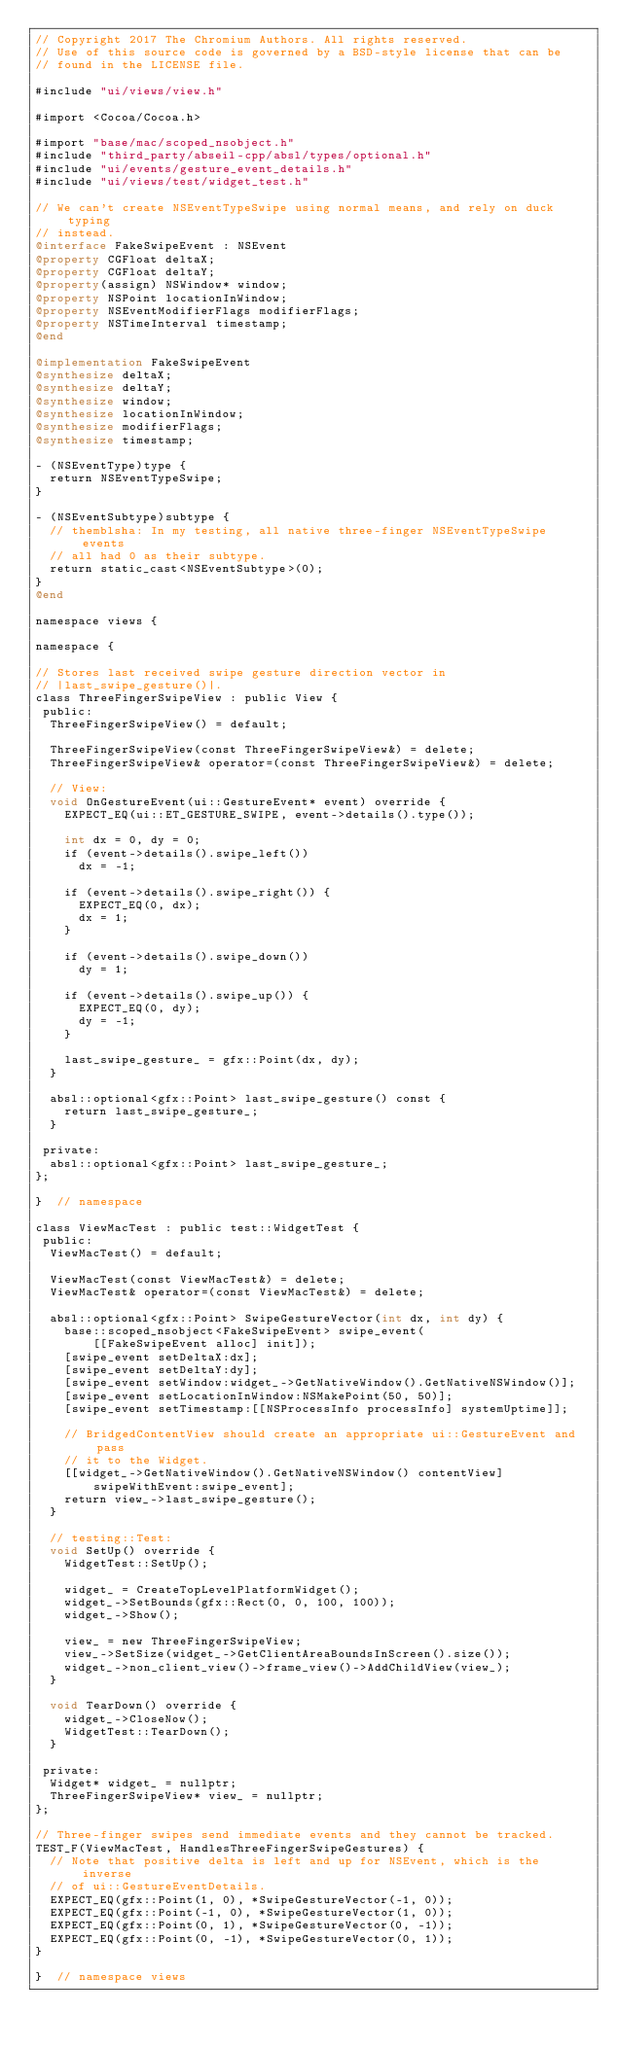<code> <loc_0><loc_0><loc_500><loc_500><_ObjectiveC_>// Copyright 2017 The Chromium Authors. All rights reserved.
// Use of this source code is governed by a BSD-style license that can be
// found in the LICENSE file.

#include "ui/views/view.h"

#import <Cocoa/Cocoa.h>

#import "base/mac/scoped_nsobject.h"
#include "third_party/abseil-cpp/absl/types/optional.h"
#include "ui/events/gesture_event_details.h"
#include "ui/views/test/widget_test.h"

// We can't create NSEventTypeSwipe using normal means, and rely on duck typing
// instead.
@interface FakeSwipeEvent : NSEvent
@property CGFloat deltaX;
@property CGFloat deltaY;
@property(assign) NSWindow* window;
@property NSPoint locationInWindow;
@property NSEventModifierFlags modifierFlags;
@property NSTimeInterval timestamp;
@end

@implementation FakeSwipeEvent
@synthesize deltaX;
@synthesize deltaY;
@synthesize window;
@synthesize locationInWindow;
@synthesize modifierFlags;
@synthesize timestamp;

- (NSEventType)type {
  return NSEventTypeSwipe;
}

- (NSEventSubtype)subtype {
  // themblsha: In my testing, all native three-finger NSEventTypeSwipe events
  // all had 0 as their subtype.
  return static_cast<NSEventSubtype>(0);
}
@end

namespace views {

namespace {

// Stores last received swipe gesture direction vector in
// |last_swipe_gesture()|.
class ThreeFingerSwipeView : public View {
 public:
  ThreeFingerSwipeView() = default;

  ThreeFingerSwipeView(const ThreeFingerSwipeView&) = delete;
  ThreeFingerSwipeView& operator=(const ThreeFingerSwipeView&) = delete;

  // View:
  void OnGestureEvent(ui::GestureEvent* event) override {
    EXPECT_EQ(ui::ET_GESTURE_SWIPE, event->details().type());

    int dx = 0, dy = 0;
    if (event->details().swipe_left())
      dx = -1;

    if (event->details().swipe_right()) {
      EXPECT_EQ(0, dx);
      dx = 1;
    }

    if (event->details().swipe_down())
      dy = 1;

    if (event->details().swipe_up()) {
      EXPECT_EQ(0, dy);
      dy = -1;
    }

    last_swipe_gesture_ = gfx::Point(dx, dy);
  }

  absl::optional<gfx::Point> last_swipe_gesture() const {
    return last_swipe_gesture_;
  }

 private:
  absl::optional<gfx::Point> last_swipe_gesture_;
};

}  // namespace

class ViewMacTest : public test::WidgetTest {
 public:
  ViewMacTest() = default;

  ViewMacTest(const ViewMacTest&) = delete;
  ViewMacTest& operator=(const ViewMacTest&) = delete;

  absl::optional<gfx::Point> SwipeGestureVector(int dx, int dy) {
    base::scoped_nsobject<FakeSwipeEvent> swipe_event(
        [[FakeSwipeEvent alloc] init]);
    [swipe_event setDeltaX:dx];
    [swipe_event setDeltaY:dy];
    [swipe_event setWindow:widget_->GetNativeWindow().GetNativeNSWindow()];
    [swipe_event setLocationInWindow:NSMakePoint(50, 50)];
    [swipe_event setTimestamp:[[NSProcessInfo processInfo] systemUptime]];

    // BridgedContentView should create an appropriate ui::GestureEvent and pass
    // it to the Widget.
    [[widget_->GetNativeWindow().GetNativeNSWindow() contentView]
        swipeWithEvent:swipe_event];
    return view_->last_swipe_gesture();
  }

  // testing::Test:
  void SetUp() override {
    WidgetTest::SetUp();

    widget_ = CreateTopLevelPlatformWidget();
    widget_->SetBounds(gfx::Rect(0, 0, 100, 100));
    widget_->Show();

    view_ = new ThreeFingerSwipeView;
    view_->SetSize(widget_->GetClientAreaBoundsInScreen().size());
    widget_->non_client_view()->frame_view()->AddChildView(view_);
  }

  void TearDown() override {
    widget_->CloseNow();
    WidgetTest::TearDown();
  }

 private:
  Widget* widget_ = nullptr;
  ThreeFingerSwipeView* view_ = nullptr;
};

// Three-finger swipes send immediate events and they cannot be tracked.
TEST_F(ViewMacTest, HandlesThreeFingerSwipeGestures) {
  // Note that positive delta is left and up for NSEvent, which is the inverse
  // of ui::GestureEventDetails.
  EXPECT_EQ(gfx::Point(1, 0), *SwipeGestureVector(-1, 0));
  EXPECT_EQ(gfx::Point(-1, 0), *SwipeGestureVector(1, 0));
  EXPECT_EQ(gfx::Point(0, 1), *SwipeGestureVector(0, -1));
  EXPECT_EQ(gfx::Point(0, -1), *SwipeGestureVector(0, 1));
}

}  // namespace views
</code> 